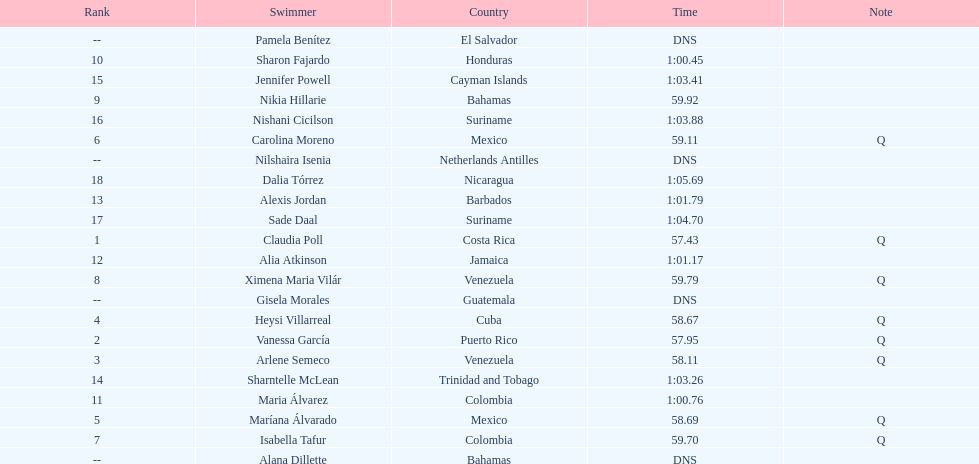What was claudia roll's time? 57.43. Could you help me parse every detail presented in this table? {'header': ['Rank', 'Swimmer', 'Country', 'Time', 'Note'], 'rows': [['--', 'Pamela Benítez', 'El Salvador', 'DNS', ''], ['10', 'Sharon Fajardo', 'Honduras', '1:00.45', ''], ['15', 'Jennifer Powell', 'Cayman Islands', '1:03.41', ''], ['9', 'Nikia Hillarie', 'Bahamas', '59.92', ''], ['16', 'Nishani Cicilson', 'Suriname', '1:03.88', ''], ['6', 'Carolina Moreno', 'Mexico', '59.11', 'Q'], ['--', 'Nilshaira Isenia', 'Netherlands Antilles', 'DNS', ''], ['18', 'Dalia Tórrez', 'Nicaragua', '1:05.69', ''], ['13', 'Alexis Jordan', 'Barbados', '1:01.79', ''], ['17', 'Sade Daal', 'Suriname', '1:04.70', ''], ['1', 'Claudia Poll', 'Costa Rica', '57.43', 'Q'], ['12', 'Alia Atkinson', 'Jamaica', '1:01.17', ''], ['8', 'Ximena Maria Vilár', 'Venezuela', '59.79', 'Q'], ['--', 'Gisela Morales', 'Guatemala', 'DNS', ''], ['4', 'Heysi Villarreal', 'Cuba', '58.67', 'Q'], ['2', 'Vanessa García', 'Puerto Rico', '57.95', 'Q'], ['3', 'Arlene Semeco', 'Venezuela', '58.11', 'Q'], ['14', 'Sharntelle McLean', 'Trinidad and Tobago', '1:03.26', ''], ['11', 'Maria Álvarez', 'Colombia', '1:00.76', ''], ['5', 'Maríana Álvarado', 'Mexico', '58.69', 'Q'], ['7', 'Isabella Tafur', 'Colombia', '59.70', 'Q'], ['--', 'Alana Dillette', 'Bahamas', 'DNS', '']]} 